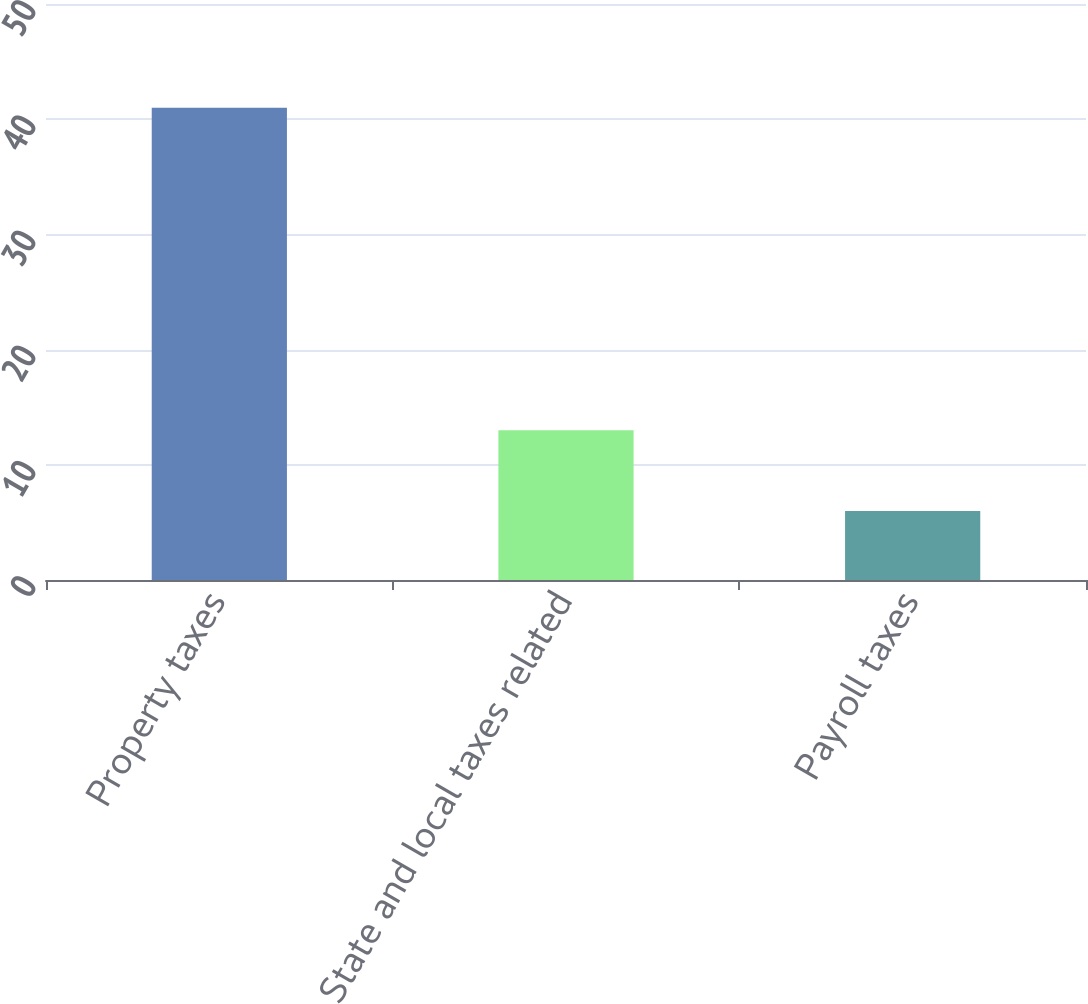<chart> <loc_0><loc_0><loc_500><loc_500><bar_chart><fcel>Property taxes<fcel>State and local taxes related<fcel>Payroll taxes<nl><fcel>41<fcel>13<fcel>6<nl></chart> 